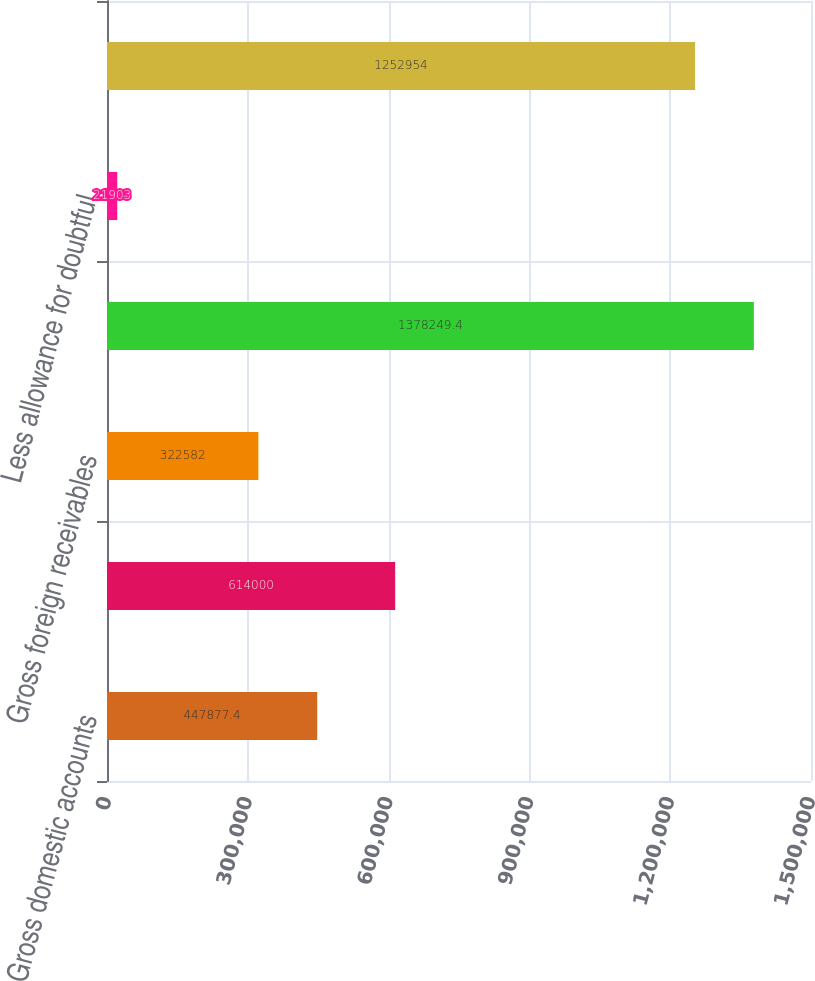Convert chart to OTSL. <chart><loc_0><loc_0><loc_500><loc_500><bar_chart><fcel>Gross domestic accounts<fcel>Gross domestic securitized<fcel>Gross foreign receivables<fcel>Total gross receivables<fcel>Less allowance for doubtful<fcel>Net accounts and securitized<nl><fcel>447877<fcel>614000<fcel>322582<fcel>1.37825e+06<fcel>21903<fcel>1.25295e+06<nl></chart> 